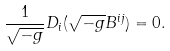<formula> <loc_0><loc_0><loc_500><loc_500>\frac { 1 } { \sqrt { - g } } D _ { i } ( \sqrt { - g } B ^ { i j } ) = 0 .</formula> 